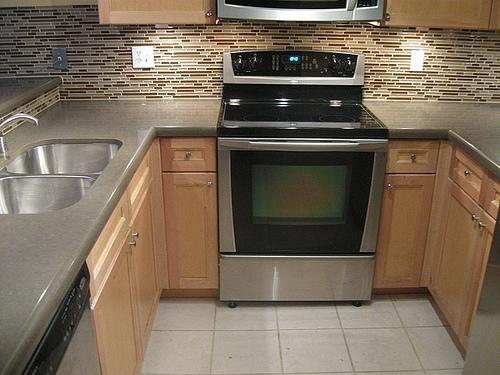Is there a dishwasher in the kitchen? If so, where is it located? Yes, there is a dishwasher in the kitchen located under the counter. Describe the material, color, and type of cabinets in the kitchen. The kitchen cabinets are made of wood, brown in color, and have knobs for opening and closing. What kind of electrical outlets are present in the kitchen and where are they located? White electrical outlets are present on the kitchen wall near the oven under a cabinet. Identify and describe the key components of the range oven in this image. The range oven is stainless steel, has a stove top, a viewing glass, and a handle. It is black and stainless steel in color. Provide a brief description of the sink in the image. The kitchen sink is a double bowl stainless steel sink with a metal finish. What are the main aspects of the microwave in the image? The microwave is stainless steel, black and stainless steel in color, and is mounted above the range oven. What type of material is the kitchen counter made of? The kitchen counter is made of granite material. Tell me about the kind of kitchen presented in this image. This is an unoccupied, clean kitchen with wooden cabinets, stainless steel appliances, including a double sink, a range oven, and a microwave, as well as a dishwasher, granite countertops, and large tan floor tiles. Examine the kitchen floor and describe its characteristics. The kitchen floor features white ceramic tiles and is large and clean. What is the general sentiment conveyed by the image of the kitchen? The image conveys a clean and well-organized unoccupied kitchen with modern appliances and a functional layout. Identify any text seen on the kitchen wall in the image. No text Explain the positioning of the microwave and the stove in the image. Microwave above the stove Is the kitchen counter made of glass? The kitchen counter is described as being made of stainless steel and granite, not glass. Is the electrical outlet next to the sink green in color? The electrical outlet is mentioned to be white, not green. Verify if the following sentence is accurate or inaccurate: The cupboard is open. Inaccurate Describe the kitchen wall using a romantic phrase. Tiled embrace of whispers Detect any event occurring in the kitchen, such as meal preparation or cleaning. No event detected Depict the color and material of the kitchen cabinets in a brief statement. Brown wooden cabinets Are the kitchen cabinets painted blue? The kitchen cabinets are mentioned to be brown and made of wood, not painted blue. Create a short, descriptive slogan for the kitchen in the image. "Crisp design for culinary delight" Is the kitchen floor covered with wooden planks? The kitchen floor is described to have white ceramic tile and large tan floor tiles, not wooden planks. Is there a person washing dishes at the sink in the image? No Explain the layout of the kitchen's appliances, focusing on their arrangement. Microwave above range, dishwasher under counter, sink beside counter Does the microwave above the range have a wooden exterior? The microwave is described as having a black and stainless steel exterior, not wooden. What text or numbers are visible on any appliances in the kitchen? None Describe two features of the kitchen sink in detail. Double bowl, stainless steel Is the oven range made of plastic? The oven range is described as being made of stainless steel and being black and stainless steel, not plastic. Select the correct statement from the following options: (a) The floor is carpeted. (b) The range is black and stainless steel. (c) The microwave is green. The range is black and stainless steel Describe the range in the kitchen using a short, poetic phrase. Stainless steel symphony What color is the electrical outlet in the kitchen? White Write a haiku poem about the kitchen in the image. Clean, unoccupied space, 